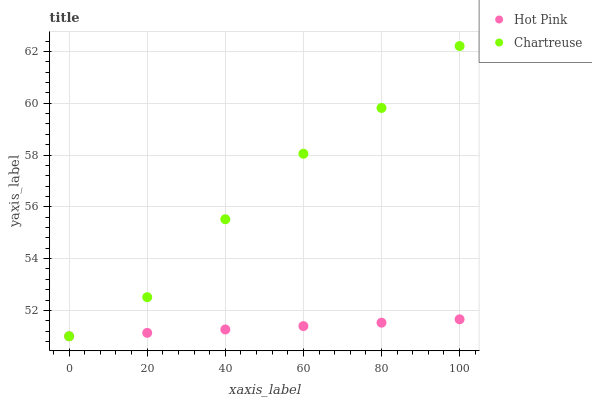Does Hot Pink have the minimum area under the curve?
Answer yes or no. Yes. Does Chartreuse have the maximum area under the curve?
Answer yes or no. Yes. Does Hot Pink have the maximum area under the curve?
Answer yes or no. No. Is Hot Pink the smoothest?
Answer yes or no. Yes. Is Chartreuse the roughest?
Answer yes or no. Yes. Is Hot Pink the roughest?
Answer yes or no. No. Does Chartreuse have the lowest value?
Answer yes or no. Yes. Does Chartreuse have the highest value?
Answer yes or no. Yes. Does Hot Pink have the highest value?
Answer yes or no. No. Does Hot Pink intersect Chartreuse?
Answer yes or no. Yes. Is Hot Pink less than Chartreuse?
Answer yes or no. No. Is Hot Pink greater than Chartreuse?
Answer yes or no. No. 